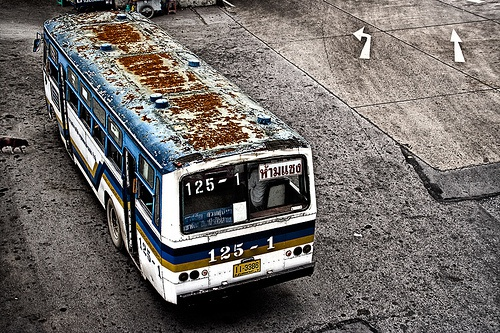Describe the objects in this image and their specific colors. I can see bus in black, white, gray, and darkgray tones, people in black and gray tones, and dog in black and gray tones in this image. 